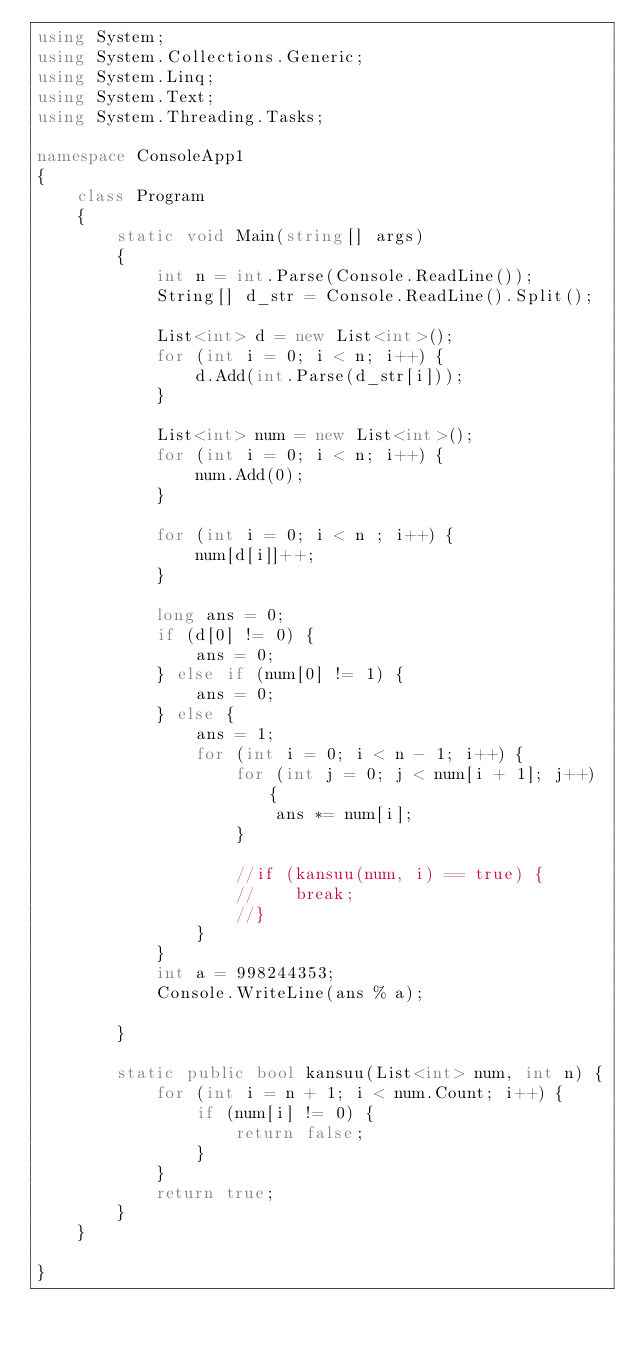<code> <loc_0><loc_0><loc_500><loc_500><_C#_>using System;
using System.Collections.Generic;
using System.Linq;
using System.Text;
using System.Threading.Tasks;

namespace ConsoleApp1
{
    class Program
    {
        static void Main(string[] args)
        {
            int n = int.Parse(Console.ReadLine());
            String[] d_str = Console.ReadLine().Split();

            List<int> d = new List<int>();
            for (int i = 0; i < n; i++) {
                d.Add(int.Parse(d_str[i]));
            }

            List<int> num = new List<int>();
            for (int i = 0; i < n; i++) {
                num.Add(0);
            }

            for (int i = 0; i < n ; i++) {
                num[d[i]]++;
            }

            long ans = 0;
            if (d[0] != 0) {
                ans = 0;
            } else if (num[0] != 1) {
                ans = 0;
            } else {
                ans = 1;
                for (int i = 0; i < n - 1; i++) {
                    for (int j = 0; j < num[i + 1]; j++) {
                        ans *= num[i];
                    }

                    //if (kansuu(num, i) == true) {
                    //    break;
                    //}
                }
            }
            int a = 998244353;
            Console.WriteLine(ans % a);

        }

        static public bool kansuu(List<int> num, int n) {
            for (int i = n + 1; i < num.Count; i++) {
                if (num[i] != 0) {
                    return false;
                }
            }
            return true;
        }
    }

}</code> 